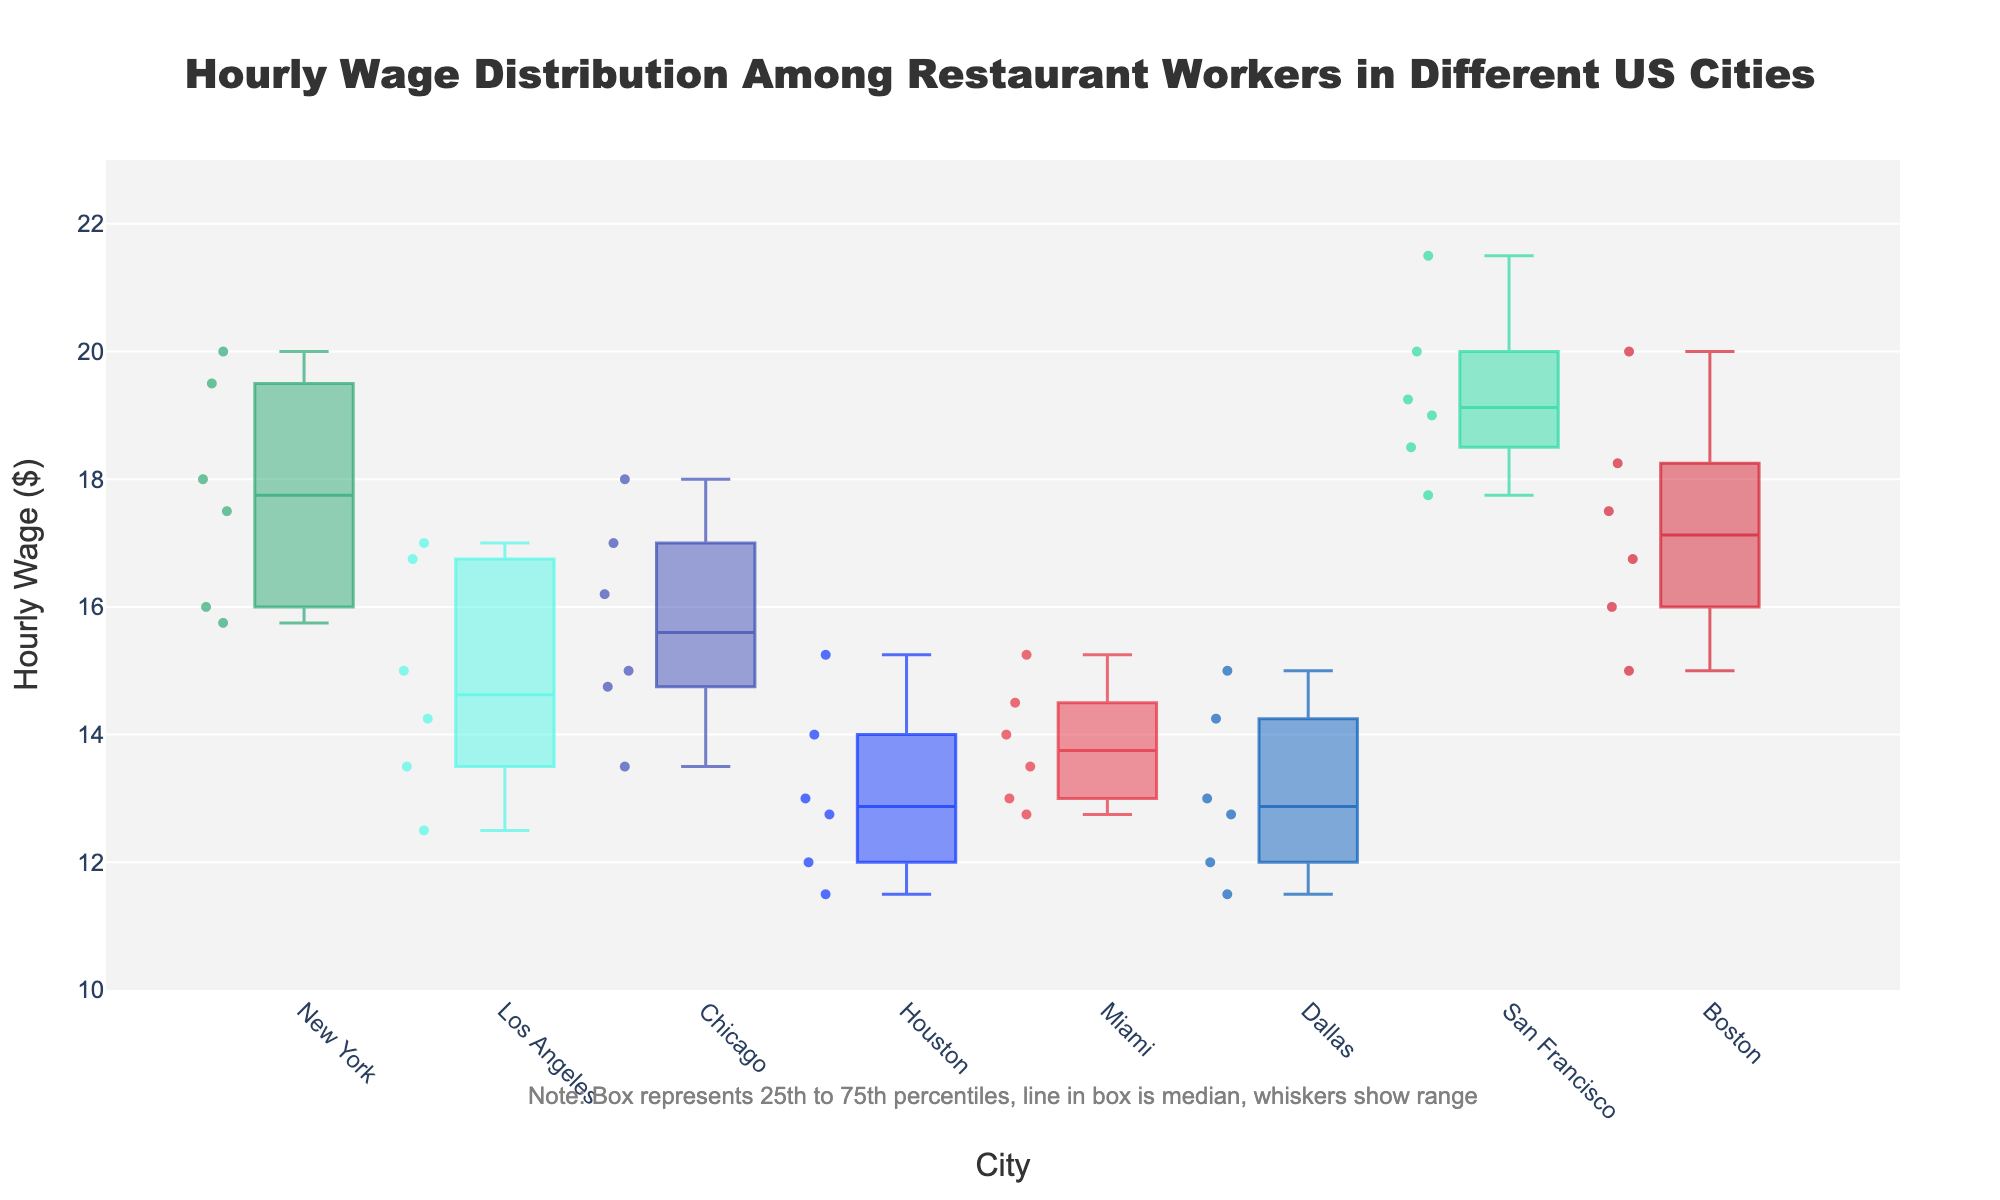what is the title of the figure? The title is displayed at the top-center of the figure and reads: "Hourly Wage Distribution Among Restaurant Workers in Different US Cities".
Answer: Hourly Wage Distribution Among Restaurant Workers in Different US Cities What is the median hourly wage in San Francisco? In a box plot, the median is represented by the line inside the box. For San Francisco, it is around $19.
Answer: $19 Which city shows the lowest minimum hourly wage? The minimum value is represented by the bottom whisker of each boxplot. Dallas has the lowest minimum hourly wage at approximately $11.50.
Answer: Dallas What is the interquartile range (IQR) for Miami? The IQR is the range between the first (25th percentile) and third quartile (75th percentile) in the box. For Miami, the IQR can be estimated from about $13 to $14.75.
Answer: $1.75 Which city has the widest range of hourly wages? The range can be determined by the distance between the top and bottom whiskers. Houston and Dallas have the widest range, spanning from approximately $11.50 to $15.25.
Answer: Houston and Dallas What cities have median hourly wages higher than $17? The median line inside the box indicates the median hourly wage. New York, San Francisco, and Boston have medians above $17.
Answer: New York, San Francisco, and Boston Which city has the highest maximum hourly wage? The top whisker represents the maximum hourly wage. San Francisco has the highest maximum at approximately $21.50.
Answer: San Francisco Which city shows the greatest variability in hourly wages? Variability can be assessed by the overall length of the box plus the whiskers. Los Angeles shows the greatest variability, ranging from approximately $12.50 to $17.
Answer: Los Angeles What is the hourly wage distribution like in New York compared to Houston? New York's wages are higher with a tighter range, from approximately $15.75 to $20, while Houston shows a lower and wider range from approximately $11.50 to $15.25.
Answer: New York has higher wages and less variability, Houston has lower wages and more variability How does the median hourly wage in Boston compare to Los Angeles? The median line inside the box for Boston is around $17 which is higher than Los Angeles' median of around $15.
Answer: Boston's median is higher than Los Angeles 